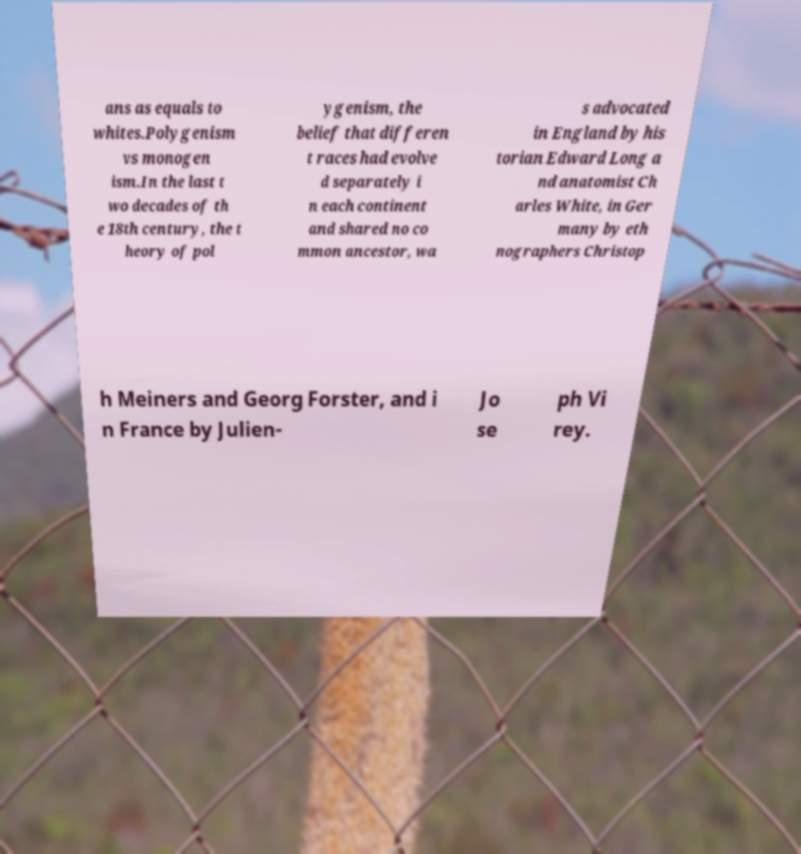Could you assist in decoding the text presented in this image and type it out clearly? ans as equals to whites.Polygenism vs monogen ism.In the last t wo decades of th e 18th century, the t heory of pol ygenism, the belief that differen t races had evolve d separately i n each continent and shared no co mmon ancestor, wa s advocated in England by his torian Edward Long a nd anatomist Ch arles White, in Ger many by eth nographers Christop h Meiners and Georg Forster, and i n France by Julien- Jo se ph Vi rey. 